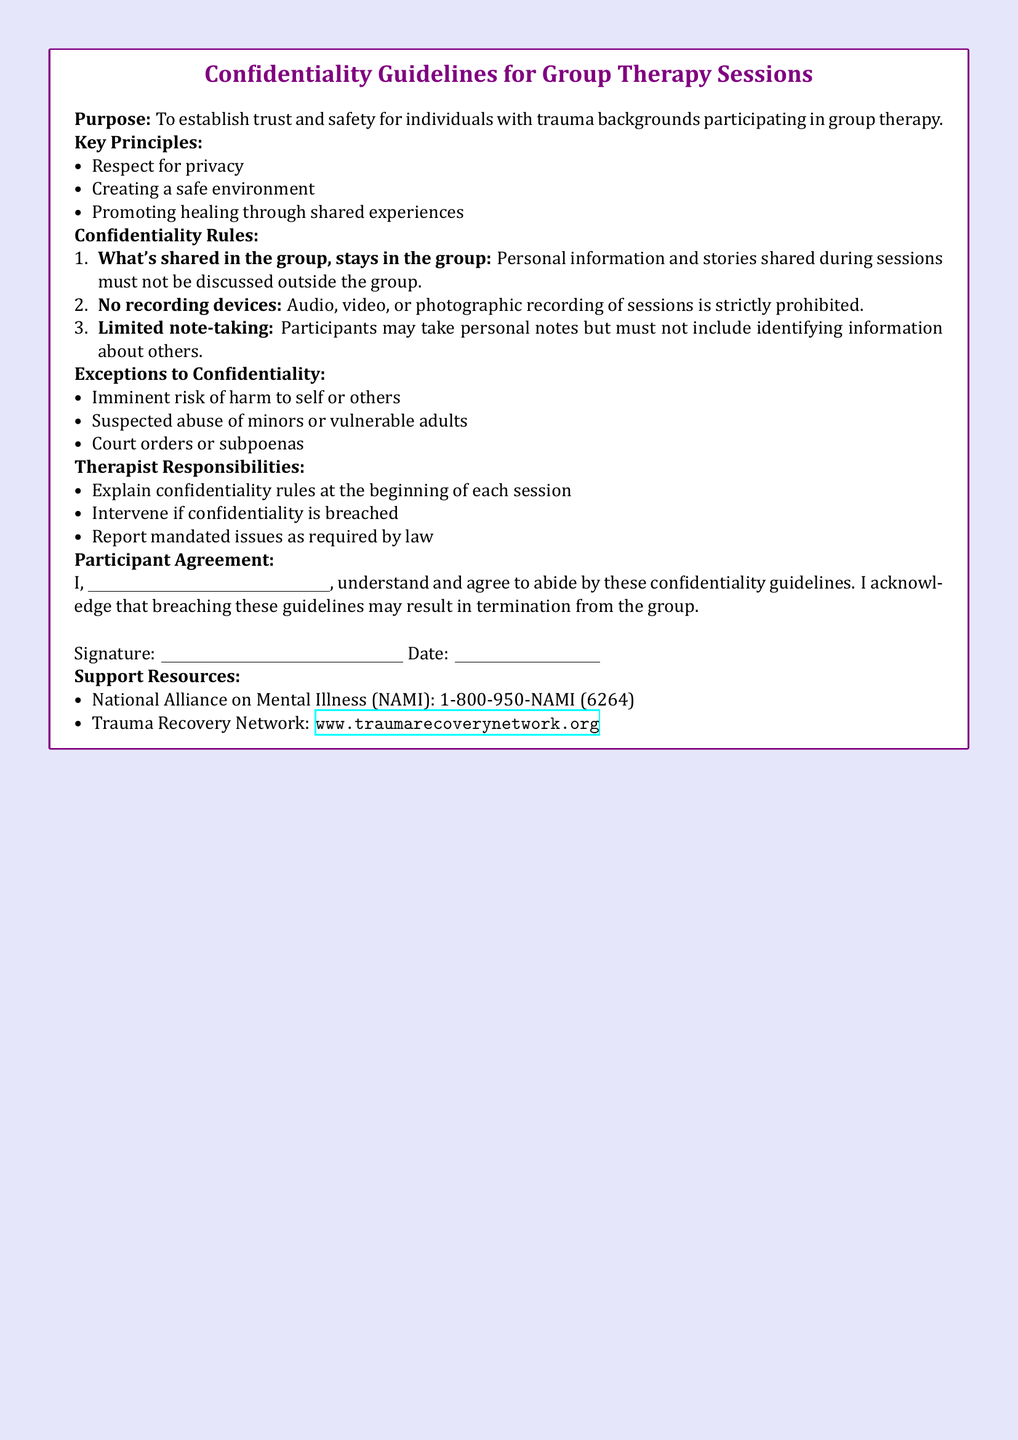What is the purpose of the confidentiality guidelines? The purpose establishes trust and safety for individuals with trauma backgrounds participating in group therapy.
Answer: To establish trust and safety What must not be discussed outside the group? The document states that personal information and stories shared during sessions must remain confidential.
Answer: Personal information and stories What is prohibited during therapy sessions? The document lists that recording devices of any kind are not allowed.
Answer: Recording devices What is one exception to confidentiality? The document outlines specific situations where confidentiality may be breached, such as the risk of harm.
Answer: Imminent risk of harm Who explains the confidentiality rules? The confidentiality rules are explained by the therapist at the beginning of each session.
Answer: Therapist What must participants not include in personal notes? The guidelines specify that notes taken must not contain identifying information about others.
Answer: Identifying information What may happen if confidentiality guidelines are breached? The document mentions that breaching can lead to termination from the group.
Answer: Termination from the group What is one resource listed for support? The document provides a specific organization that offers support resources for individuals.
Answer: National Alliance on Mental Illness (NAMI) 